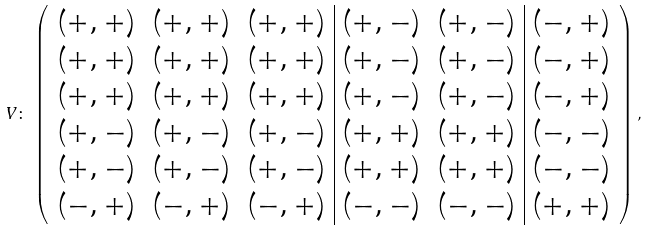<formula> <loc_0><loc_0><loc_500><loc_500>V \colon \, \left ( \begin{array} { c c c | c c | c } ( + , + ) & ( + , + ) & ( + , + ) & ( + , - ) & ( + , - ) & ( - , + ) \\ ( + , + ) & ( + , + ) & ( + , + ) & ( + , - ) & ( + , - ) & ( - , + ) \\ ( + , + ) & ( + , + ) & ( + , + ) & ( + , - ) & ( + , - ) & ( - , + ) \\ ( + , - ) & ( + , - ) & ( + , - ) & ( + , + ) & ( + , + ) & ( - , - ) \\ ( + , - ) & ( + , - ) & ( + , - ) & ( + , + ) & ( + , + ) & ( - , - ) \\ ( - , + ) & ( - , + ) & ( - , + ) & ( - , - ) & ( - , - ) & ( + , + ) \end{array} \right ) ,</formula> 